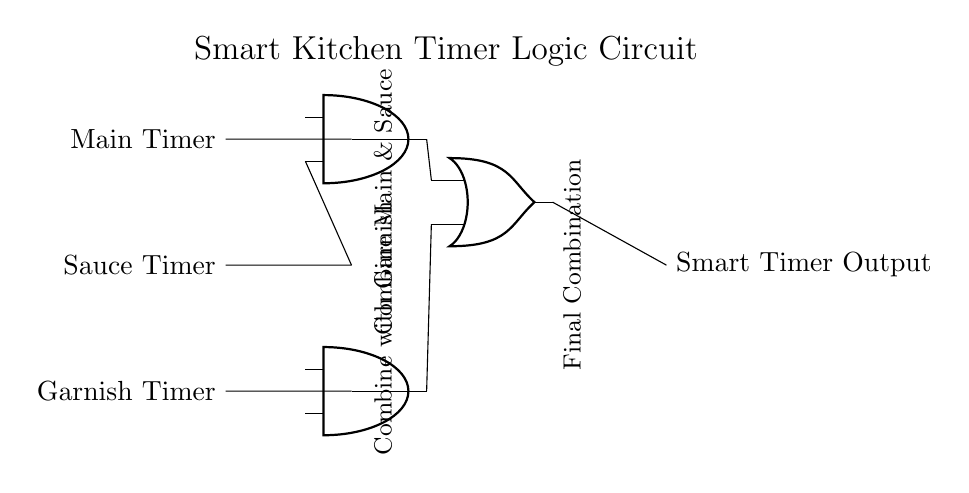What is the function of the AND gates in this circuit? The AND gates combine multiple signals: one AND gate combines the Main Timer and Sauce Timer, while the other combines that output with the Garnish Timer. This ensures outputs are only active when both signals are present.
Answer: Combine signals What type of logic gate is used to finalize the output? The final output is produced by an OR gate, which takes inputs from the two AND gates and outputs when at least one input is high.
Answer: OR gate How many input timers are there in the circuit? There are three input timers: Main Timer, Sauce Timer, and Garnish Timer. These inputs are fed into the logic gates.
Answer: Three What is the output of the circuit when all timers are active? When all timers are active, both AND gates will output a high signal, leading the OR gate to produce an active output as well.
Answer: Active output What is the purpose of the OR gate in this circuit? The OR gate combines the outputs of the AND gates, ensuring the final output is active if either combination of inputs is present.
Answer: Combine outputs Which component in this circuit connects the AND gates to the output? The OR gate connects the outputs of the AND gates to the final output of the Smart Timer.
Answer: OR gate 